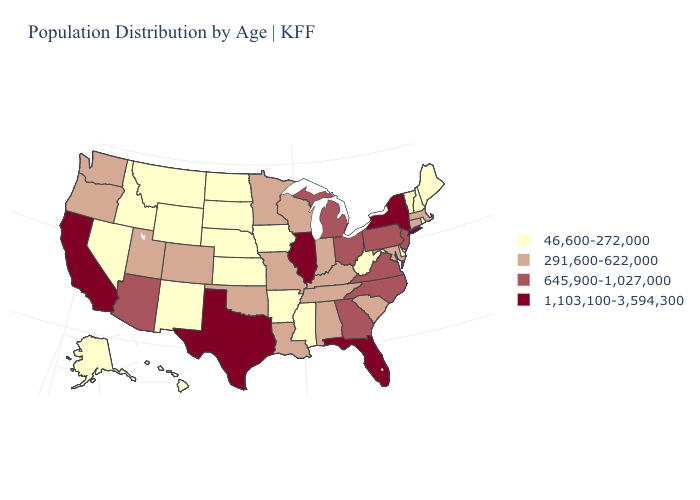Name the states that have a value in the range 291,600-622,000?
Give a very brief answer. Alabama, Colorado, Connecticut, Indiana, Kentucky, Louisiana, Maryland, Massachusetts, Minnesota, Missouri, Oklahoma, Oregon, South Carolina, Tennessee, Utah, Washington, Wisconsin. Among the states that border Kentucky , does Indiana have the lowest value?
Short answer required. No. Name the states that have a value in the range 46,600-272,000?
Answer briefly. Alaska, Arkansas, Delaware, Hawaii, Idaho, Iowa, Kansas, Maine, Mississippi, Montana, Nebraska, Nevada, New Hampshire, New Mexico, North Dakota, Rhode Island, South Dakota, Vermont, West Virginia, Wyoming. Does Massachusetts have a higher value than North Dakota?
Write a very short answer. Yes. What is the value of Colorado?
Short answer required. 291,600-622,000. Does Iowa have a higher value than Hawaii?
Be succinct. No. What is the value of Nebraska?
Be succinct. 46,600-272,000. Which states have the lowest value in the Northeast?
Be succinct. Maine, New Hampshire, Rhode Island, Vermont. What is the highest value in the USA?
Quick response, please. 1,103,100-3,594,300. Name the states that have a value in the range 46,600-272,000?
Keep it brief. Alaska, Arkansas, Delaware, Hawaii, Idaho, Iowa, Kansas, Maine, Mississippi, Montana, Nebraska, Nevada, New Hampshire, New Mexico, North Dakota, Rhode Island, South Dakota, Vermont, West Virginia, Wyoming. Does South Carolina have the lowest value in the USA?
Keep it brief. No. What is the lowest value in states that border Texas?
Quick response, please. 46,600-272,000. Does the map have missing data?
Answer briefly. No. Which states have the lowest value in the USA?
Quick response, please. Alaska, Arkansas, Delaware, Hawaii, Idaho, Iowa, Kansas, Maine, Mississippi, Montana, Nebraska, Nevada, New Hampshire, New Mexico, North Dakota, Rhode Island, South Dakota, Vermont, West Virginia, Wyoming. 